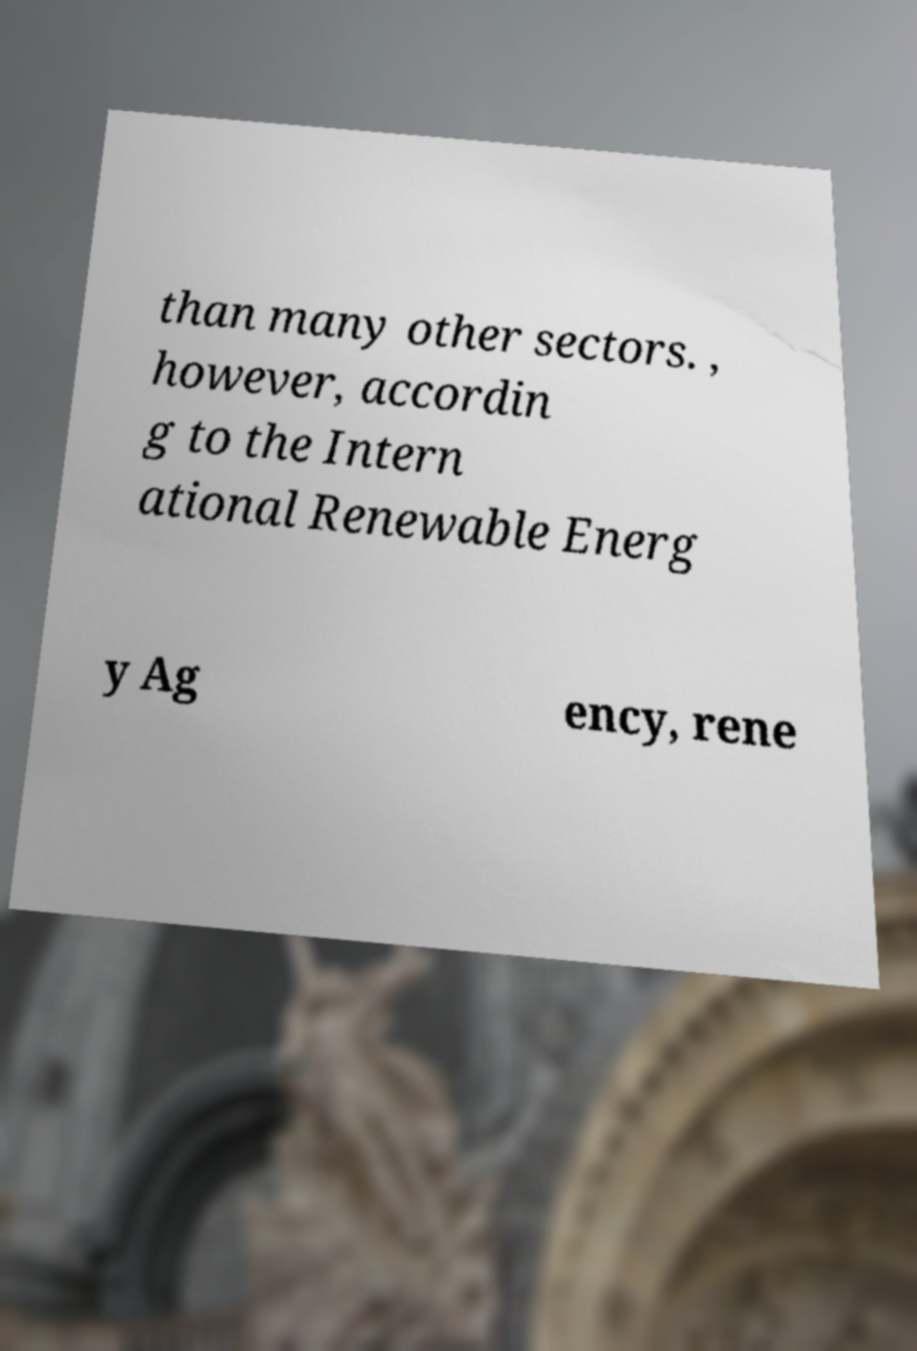Please read and relay the text visible in this image. What does it say? than many other sectors. , however, accordin g to the Intern ational Renewable Energ y Ag ency, rene 